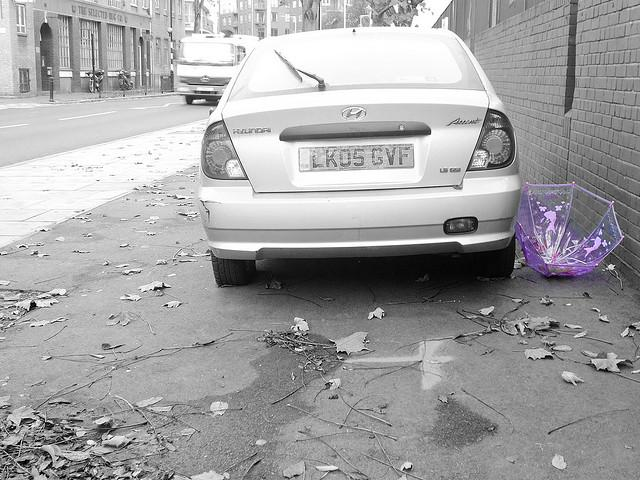What is this model of car called in South Korea? hyundai 